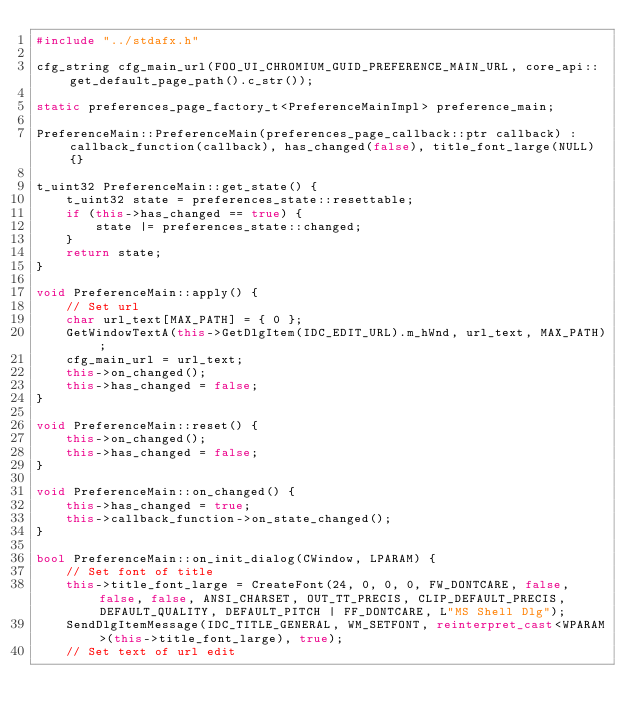<code> <loc_0><loc_0><loc_500><loc_500><_C++_>#include "../stdafx.h"

cfg_string cfg_main_url(FOO_UI_CHROMIUM_GUID_PREFERENCE_MAIN_URL, core_api::get_default_page_path().c_str());

static preferences_page_factory_t<PreferenceMainImpl> preference_main;

PreferenceMain::PreferenceMain(preferences_page_callback::ptr callback) : callback_function(callback), has_changed(false), title_font_large(NULL) {}

t_uint32 PreferenceMain::get_state() {
	t_uint32 state = preferences_state::resettable;
	if (this->has_changed == true) {
		state |= preferences_state::changed;
	}
	return state;
}

void PreferenceMain::apply() {
	// Set url
	char url_text[MAX_PATH] = { 0 };
	GetWindowTextA(this->GetDlgItem(IDC_EDIT_URL).m_hWnd, url_text, MAX_PATH);
	cfg_main_url = url_text;
	this->on_changed();
	this->has_changed = false;
}

void PreferenceMain::reset() {
	this->on_changed();
	this->has_changed = false;
}

void PreferenceMain::on_changed() {
	this->has_changed = true;
	this->callback_function->on_state_changed();
}

bool PreferenceMain::on_init_dialog(CWindow, LPARAM) {
	// Set font of title
	this->title_font_large = CreateFont(24, 0, 0, 0, FW_DONTCARE, false, false, false, ANSI_CHARSET, OUT_TT_PRECIS, CLIP_DEFAULT_PRECIS, DEFAULT_QUALITY, DEFAULT_PITCH | FF_DONTCARE, L"MS Shell Dlg");
	SendDlgItemMessage(IDC_TITLE_GENERAL, WM_SETFONT, reinterpret_cast<WPARAM>(this->title_font_large), true);
	// Set text of url edit</code> 